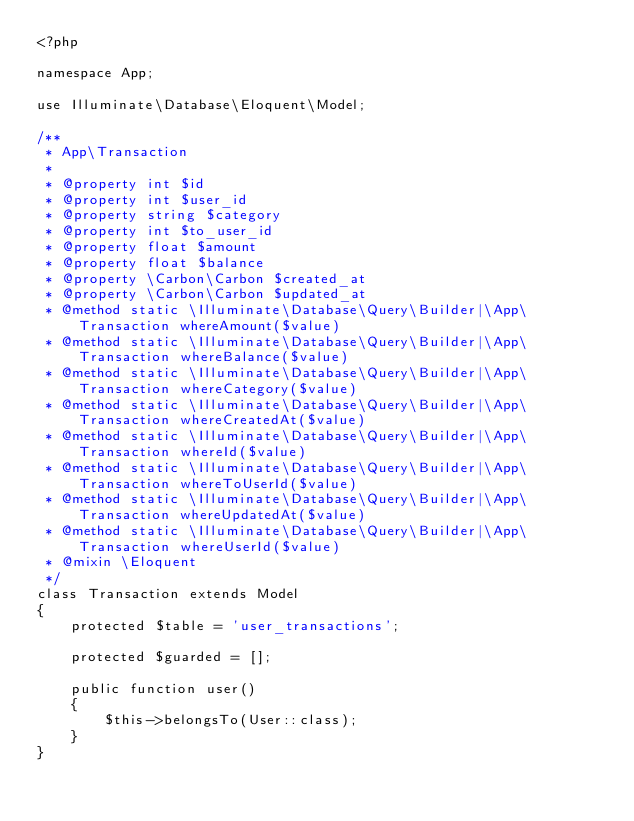Convert code to text. <code><loc_0><loc_0><loc_500><loc_500><_PHP_><?php

namespace App;

use Illuminate\Database\Eloquent\Model;

/**
 * App\Transaction
 *
 * @property int $id
 * @property int $user_id
 * @property string $category
 * @property int $to_user_id
 * @property float $amount
 * @property float $balance
 * @property \Carbon\Carbon $created_at
 * @property \Carbon\Carbon $updated_at
 * @method static \Illuminate\Database\Query\Builder|\App\Transaction whereAmount($value)
 * @method static \Illuminate\Database\Query\Builder|\App\Transaction whereBalance($value)
 * @method static \Illuminate\Database\Query\Builder|\App\Transaction whereCategory($value)
 * @method static \Illuminate\Database\Query\Builder|\App\Transaction whereCreatedAt($value)
 * @method static \Illuminate\Database\Query\Builder|\App\Transaction whereId($value)
 * @method static \Illuminate\Database\Query\Builder|\App\Transaction whereToUserId($value)
 * @method static \Illuminate\Database\Query\Builder|\App\Transaction whereUpdatedAt($value)
 * @method static \Illuminate\Database\Query\Builder|\App\Transaction whereUserId($value)
 * @mixin \Eloquent
 */
class Transaction extends Model
{
    protected $table = 'user_transactions';

    protected $guarded = [];

    public function user()
    {
        $this->belongsTo(User::class);
    }
}
</code> 